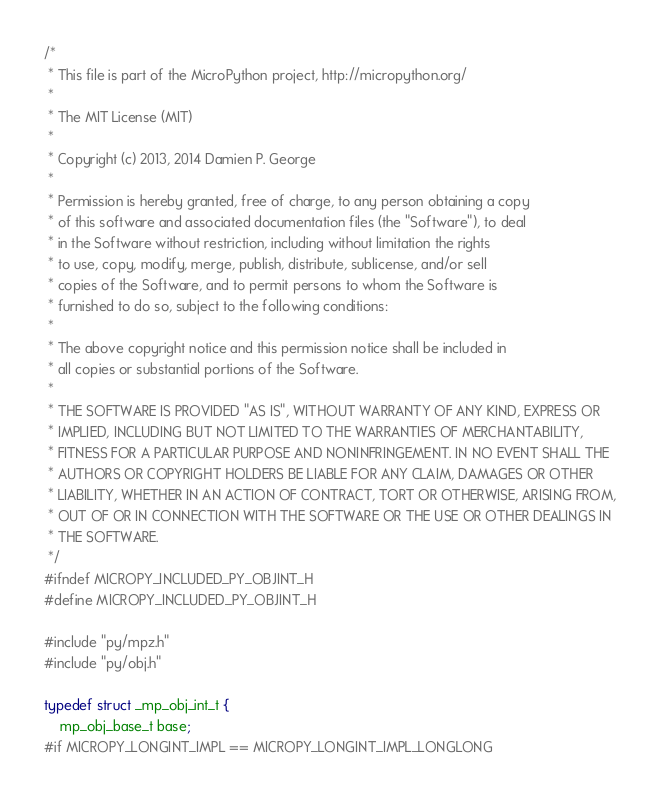Convert code to text. <code><loc_0><loc_0><loc_500><loc_500><_C_>/*
 * This file is part of the MicroPython project, http://micropython.org/
 *
 * The MIT License (MIT)
 *
 * Copyright (c) 2013, 2014 Damien P. George
 *
 * Permission is hereby granted, free of charge, to any person obtaining a copy
 * of this software and associated documentation files (the "Software"), to deal
 * in the Software without restriction, including without limitation the rights
 * to use, copy, modify, merge, publish, distribute, sublicense, and/or sell
 * copies of the Software, and to permit persons to whom the Software is
 * furnished to do so, subject to the following conditions:
 *
 * The above copyright notice and this permission notice shall be included in
 * all copies or substantial portions of the Software.
 *
 * THE SOFTWARE IS PROVIDED "AS IS", WITHOUT WARRANTY OF ANY KIND, EXPRESS OR
 * IMPLIED, INCLUDING BUT NOT LIMITED TO THE WARRANTIES OF MERCHANTABILITY,
 * FITNESS FOR A PARTICULAR PURPOSE AND NONINFRINGEMENT. IN NO EVENT SHALL THE
 * AUTHORS OR COPYRIGHT HOLDERS BE LIABLE FOR ANY CLAIM, DAMAGES OR OTHER
 * LIABILITY, WHETHER IN AN ACTION OF CONTRACT, TORT OR OTHERWISE, ARISING FROM,
 * OUT OF OR IN CONNECTION WITH THE SOFTWARE OR THE USE OR OTHER DEALINGS IN
 * THE SOFTWARE.
 */
#ifndef MICROPY_INCLUDED_PY_OBJINT_H
#define MICROPY_INCLUDED_PY_OBJINT_H

#include "py/mpz.h"
#include "py/obj.h"

typedef struct _mp_obj_int_t {
    mp_obj_base_t base;
#if MICROPY_LONGINT_IMPL == MICROPY_LONGINT_IMPL_LONGLONG</code> 